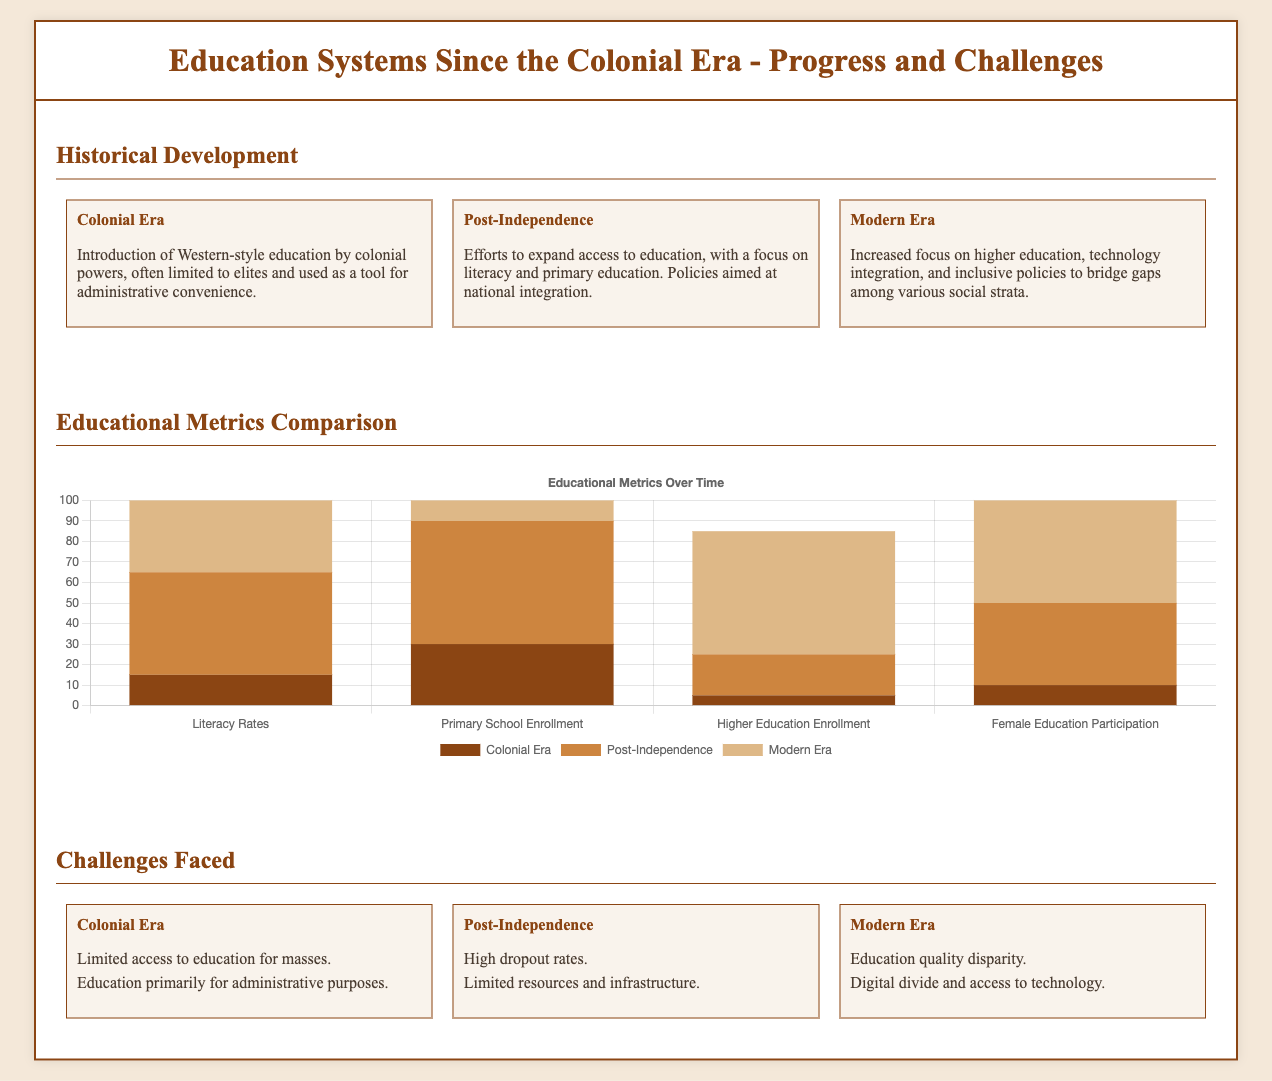what was the literacy rate during the Colonial Era? The document states that the literacy rate during the Colonial Era was 15%.
Answer: 15% what percentage of primary school enrollment was achieved in the Modern Era? According to the chart, primary school enrollment in the Modern Era reached 95%.
Answer: 95% which era focused on expanding access to education primarily? The document indicates that the Post-Independence era focused on expanding access to education.
Answer: Post-Independence what was a major challenge faced during the Modern Era? The document lists education quality disparity as a major challenge faced during the Modern Era.
Answer: Education quality disparity how many metrics are compared in the educational metrics section? The chart compares four educational metrics: Literacy Rates, Primary School Enrollment, Higher Education Enrollment, and Female Education Participation.
Answer: Four what is the description of the Colonial Era education system? The document describes it as an introduction of Western-style education limited to elites and used for administrative convenience.
Answer: Limited to elites what was the female education participation percentage in the Colonial Era? According to the chart, the female education participation percentage during the Colonial Era was 10%.
Answer: 10% which educational metric had the highest percentage in the Modern Era? The chart shows that the highest percentage in the Modern Era was for Literacy Rates at 85%.
Answer: Literacy Rates what is a common challenge from the Colonial Era educational system? The document identifies limited access to education for the masses as a common challenge from the Colonial Era.
Answer: Limited access to education 